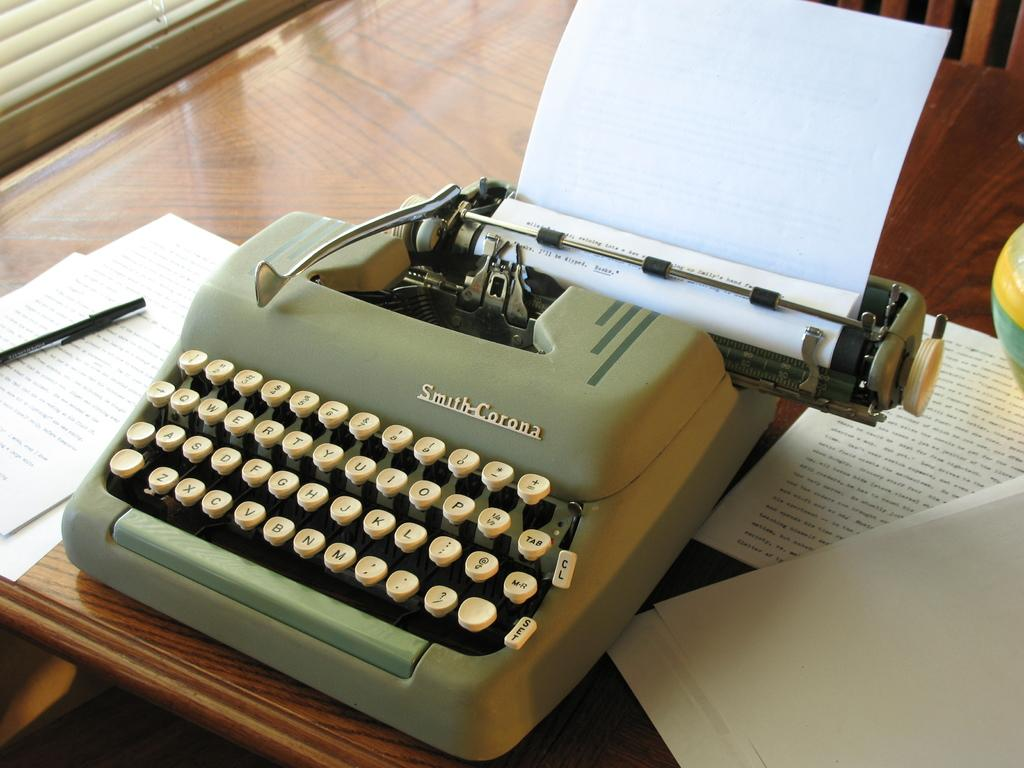<image>
Offer a succinct explanation of the picture presented. A typewriter has the brand name Smith-Corona on the top. 